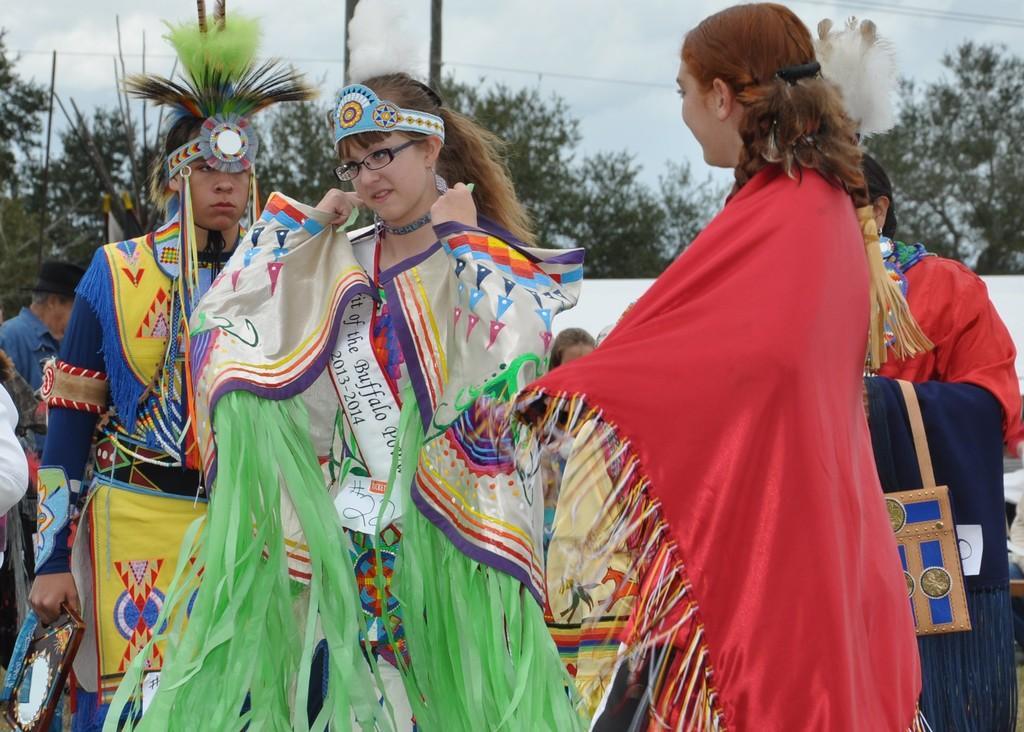Describe this image in one or two sentences. In this image, we can see a group of people with different kind of dresses. In the background, we can see some trees, poles, electric wires. At the top, we can see a sky. 